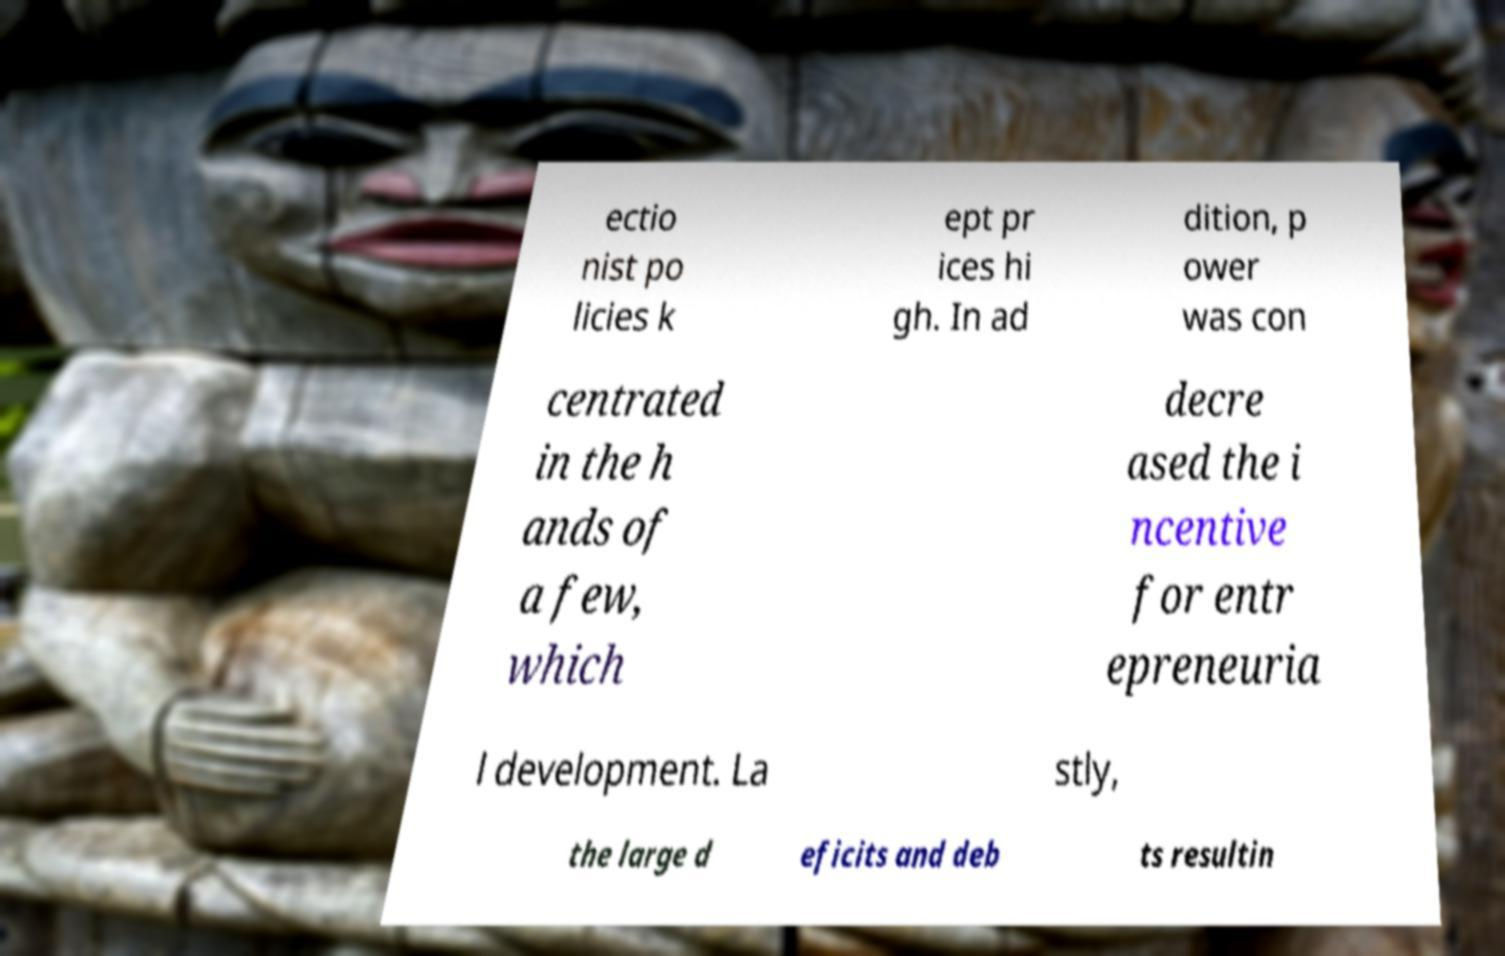There's text embedded in this image that I need extracted. Can you transcribe it verbatim? ectio nist po licies k ept pr ices hi gh. In ad dition, p ower was con centrated in the h ands of a few, which decre ased the i ncentive for entr epreneuria l development. La stly, the large d eficits and deb ts resultin 